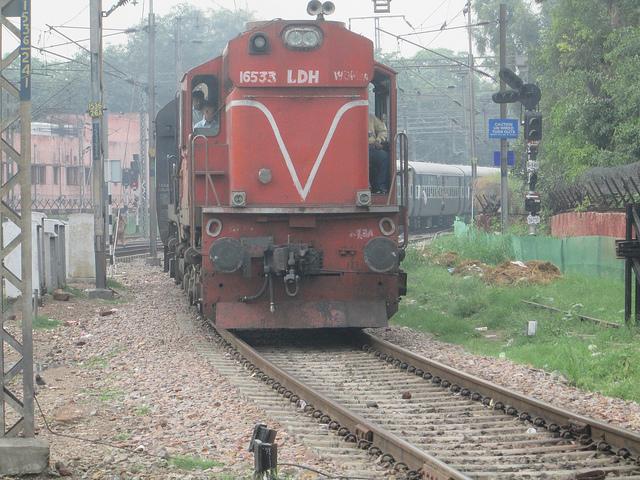What are the letters on this train?
Answer briefly. Ldh. What color is the train?
Be succinct. Red. Are there any animals in this picture?
Quick response, please. No. Is there snow on the ground?
Keep it brief. No. 